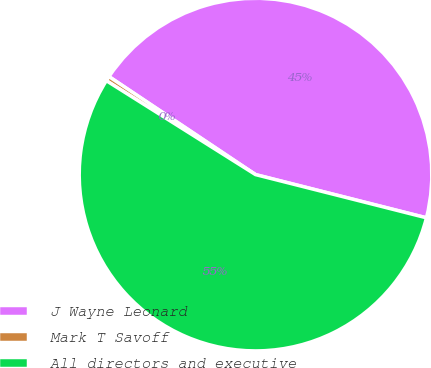Convert chart. <chart><loc_0><loc_0><loc_500><loc_500><pie_chart><fcel>J Wayne Leonard<fcel>Mark T Savoff<fcel>All directors and executive<nl><fcel>44.56%<fcel>0.44%<fcel>55.0%<nl></chart> 